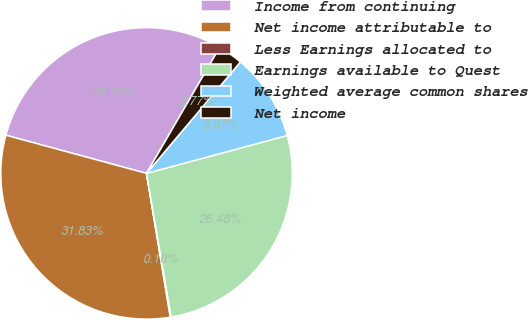Convert chart to OTSL. <chart><loc_0><loc_0><loc_500><loc_500><pie_chart><fcel>Income from continuing<fcel>Net income attributable to<fcel>Less Earnings allocated to<fcel>Earnings available to Quest<fcel>Weighted average common shares<fcel>Net income<nl><fcel>29.16%<fcel>31.83%<fcel>0.1%<fcel>26.48%<fcel>9.67%<fcel>2.77%<nl></chart> 